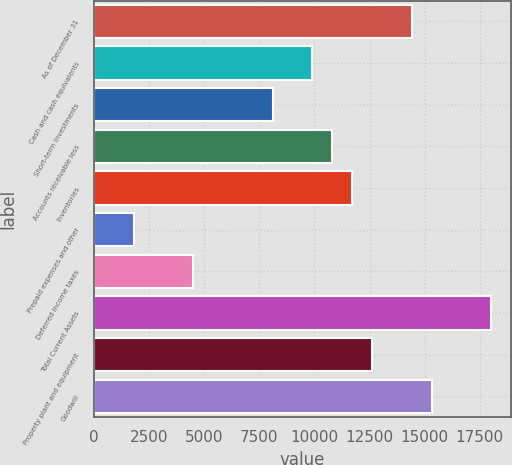Convert chart to OTSL. <chart><loc_0><loc_0><loc_500><loc_500><bar_chart><fcel>As of December 31<fcel>Cash and cash equivalents<fcel>Short-term investments<fcel>Accounts receivable less<fcel>Inventories<fcel>Prepaid expenses and other<fcel>Deferred income taxes<fcel>Total Current Assets<fcel>Property plant and equipment<fcel>Goodwill<nl><fcel>14418.3<fcel>9913.38<fcel>8111.42<fcel>10814.4<fcel>11715.3<fcel>1804.56<fcel>4507.5<fcel>18022.2<fcel>12616.3<fcel>15319.3<nl></chart> 